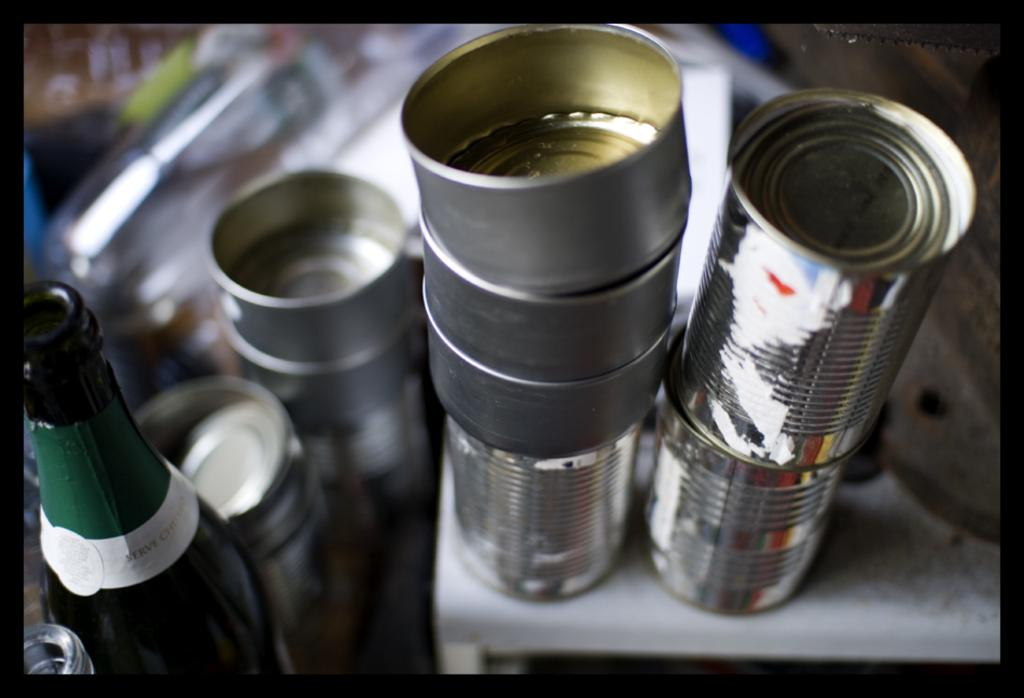What object is located on the left side of the image? There is a bottle on the left side of the image. What type of objects resemble the number ten in the image? There are objects that look like tens in the image. Can you describe the background of the image? The background of the image is blurred. How does the finger help in comparing the insurance policies in the image? There is no finger, comparison, or insurance policies present in the image. 